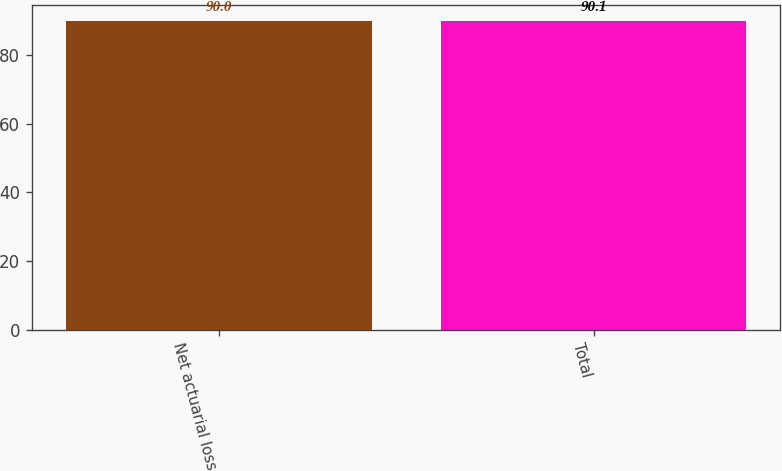Convert chart. <chart><loc_0><loc_0><loc_500><loc_500><bar_chart><fcel>Net actuarial loss<fcel>Total<nl><fcel>90<fcel>90.1<nl></chart> 